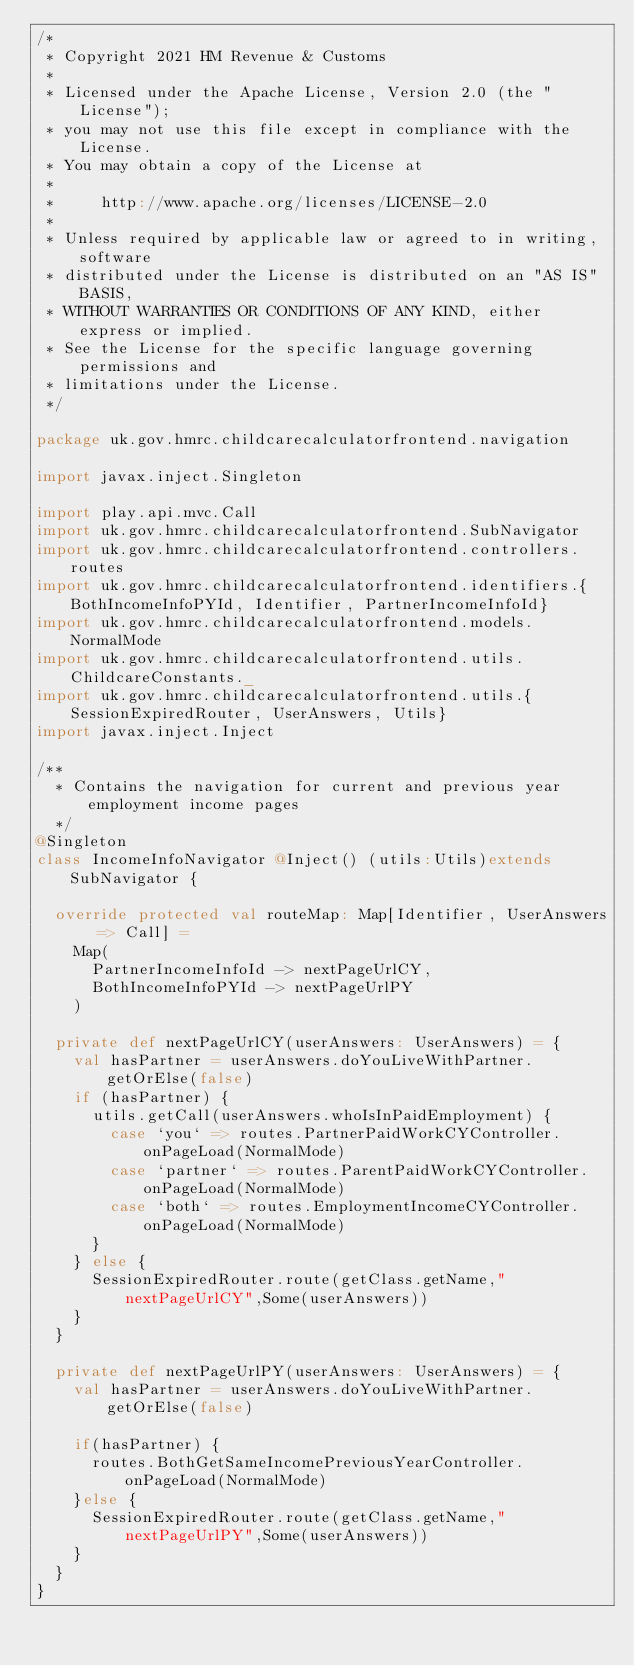<code> <loc_0><loc_0><loc_500><loc_500><_Scala_>/*
 * Copyright 2021 HM Revenue & Customs
 *
 * Licensed under the Apache License, Version 2.0 (the "License");
 * you may not use this file except in compliance with the License.
 * You may obtain a copy of the License at
 *
 *     http://www.apache.org/licenses/LICENSE-2.0
 *
 * Unless required by applicable law or agreed to in writing, software
 * distributed under the License is distributed on an "AS IS" BASIS,
 * WITHOUT WARRANTIES OR CONDITIONS OF ANY KIND, either express or implied.
 * See the License for the specific language governing permissions and
 * limitations under the License.
 */

package uk.gov.hmrc.childcarecalculatorfrontend.navigation

import javax.inject.Singleton

import play.api.mvc.Call
import uk.gov.hmrc.childcarecalculatorfrontend.SubNavigator
import uk.gov.hmrc.childcarecalculatorfrontend.controllers.routes
import uk.gov.hmrc.childcarecalculatorfrontend.identifiers.{BothIncomeInfoPYId, Identifier, PartnerIncomeInfoId}
import uk.gov.hmrc.childcarecalculatorfrontend.models.NormalMode
import uk.gov.hmrc.childcarecalculatorfrontend.utils.ChildcareConstants._
import uk.gov.hmrc.childcarecalculatorfrontend.utils.{SessionExpiredRouter, UserAnswers, Utils}
import javax.inject.Inject

/**
  * Contains the navigation for current and previous year employment income pages
  */
@Singleton
class IncomeInfoNavigator @Inject() (utils:Utils)extends SubNavigator {

  override protected val routeMap: Map[Identifier, UserAnswers => Call] =
    Map(
      PartnerIncomeInfoId -> nextPageUrlCY,
      BothIncomeInfoPYId -> nextPageUrlPY
    )

  private def nextPageUrlCY(userAnswers: UserAnswers) = {
    val hasPartner = userAnswers.doYouLiveWithPartner.getOrElse(false)
    if (hasPartner) {
      utils.getCall(userAnswers.whoIsInPaidEmployment) {
        case `you` => routes.PartnerPaidWorkCYController.onPageLoad(NormalMode)
        case `partner` => routes.ParentPaidWorkCYController.onPageLoad(NormalMode)
        case `both` => routes.EmploymentIncomeCYController.onPageLoad(NormalMode)
      }
    } else {
      SessionExpiredRouter.route(getClass.getName,"nextPageUrlCY",Some(userAnswers))
    }
  }

  private def nextPageUrlPY(userAnswers: UserAnswers) = {
    val hasPartner = userAnswers.doYouLiveWithPartner.getOrElse(false)

    if(hasPartner) {
      routes.BothGetSameIncomePreviousYearController.onPageLoad(NormalMode)
    }else {
      SessionExpiredRouter.route(getClass.getName,"nextPageUrlPY",Some(userAnswers))
    }
  }
}
</code> 